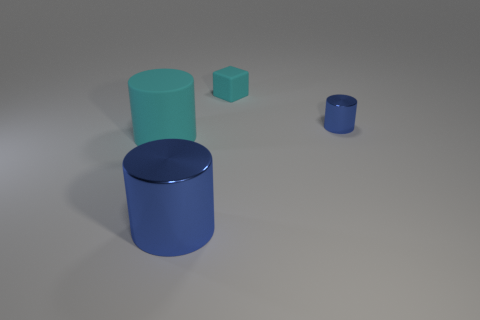Add 3 tiny cyan rubber things. How many objects exist? 7 Subtract all cylinders. How many objects are left? 1 Subtract 0 red cylinders. How many objects are left? 4 Subtract all small blue shiny things. Subtract all cyan things. How many objects are left? 1 Add 4 cyan cylinders. How many cyan cylinders are left? 5 Add 4 large brown matte spheres. How many large brown matte spheres exist? 4 